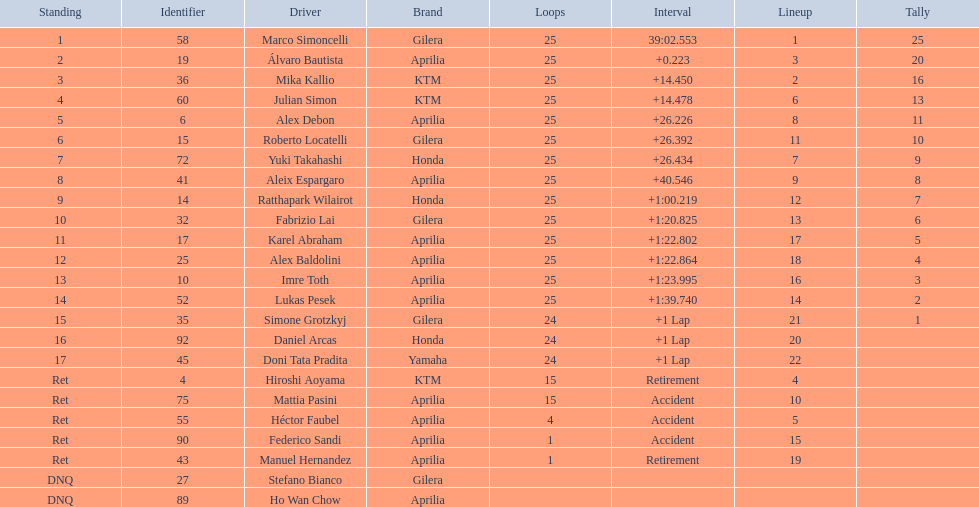The next rider from italy aside from winner marco simoncelli was Roberto Locatelli. 